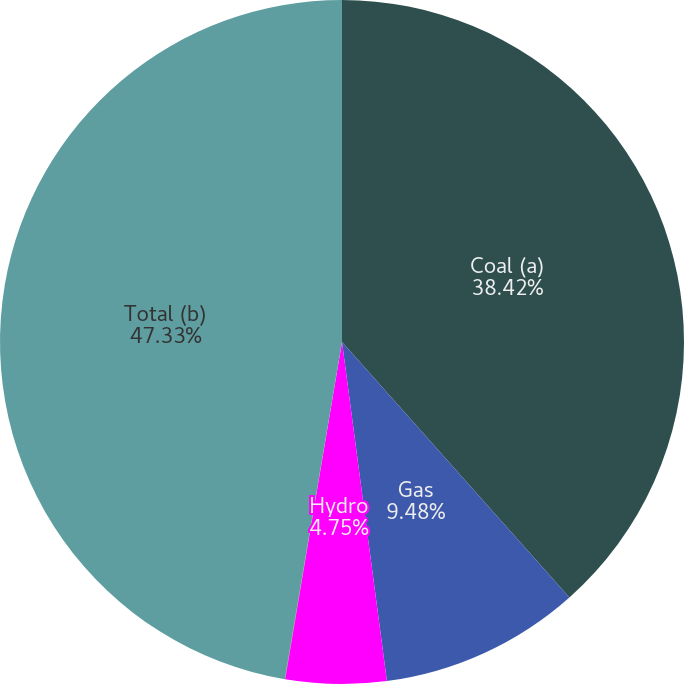Convert chart to OTSL. <chart><loc_0><loc_0><loc_500><loc_500><pie_chart><fcel>Coal (a)<fcel>Gas<fcel>Hydro<fcel>Solar<fcel>Total (b)<nl><fcel>38.42%<fcel>9.48%<fcel>4.75%<fcel>0.02%<fcel>47.32%<nl></chart> 